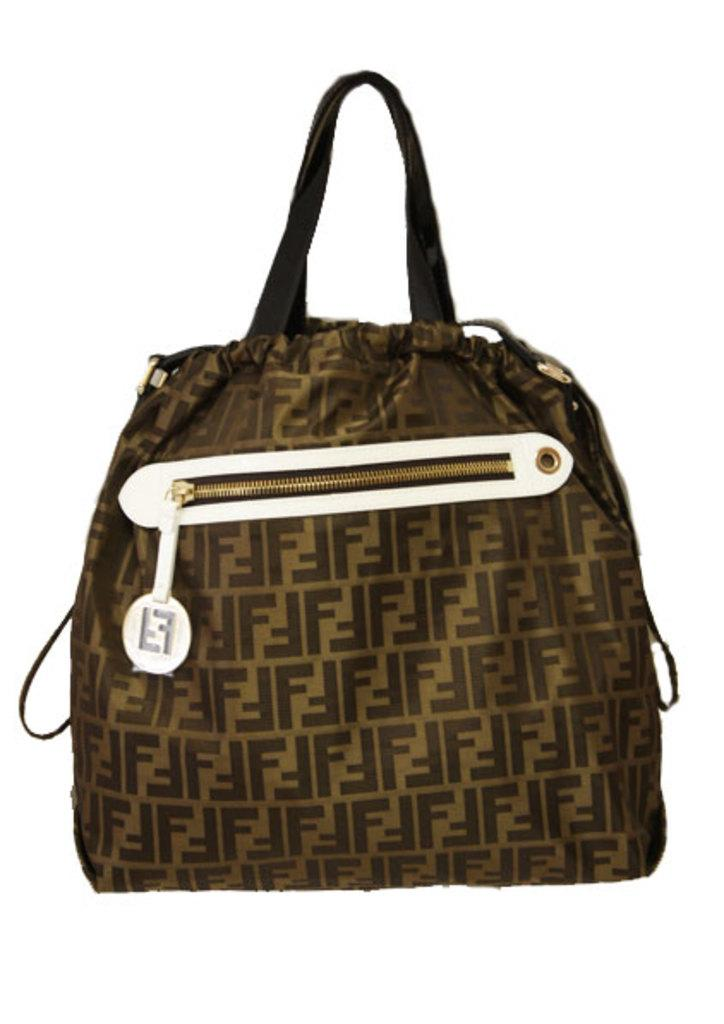What type of accessory is present in the image? There is a handbag in the image. Can you describe the color of the handbag? The handbag is brown and gold in color. Does the handbag have any specific features? Yes, the handbag has a zip facility and a label attached to the zip. How would you describe the texture of the handbag? The handbag has a beautifully printed texture. What type of jewel is being used to take a bath in the image? There is no jewel or bathing activity present in the image; it features a handbag. 